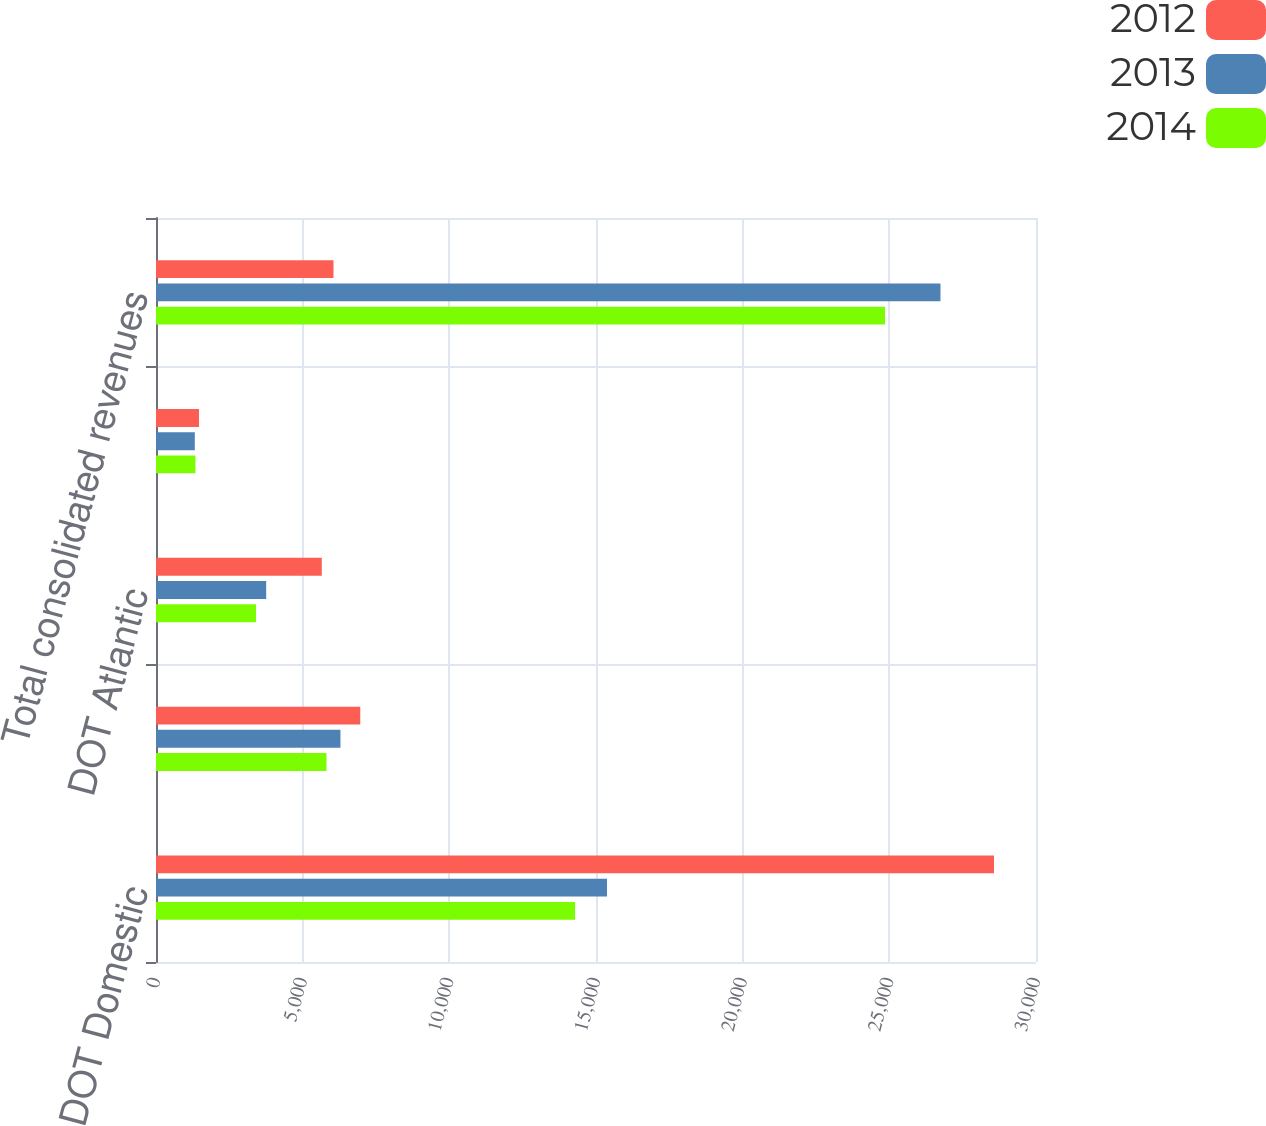<chart> <loc_0><loc_0><loc_500><loc_500><stacked_bar_chart><ecel><fcel>DOT Domestic<fcel>DOT Latin America<fcel>DOT Atlantic<fcel>DOT Pacific<fcel>Total consolidated revenues<nl><fcel>2012<fcel>28568<fcel>6964<fcel>5652<fcel>1466<fcel>6050.5<nl><fcel>2013<fcel>15376<fcel>6288<fcel>3756<fcel>1323<fcel>26743<nl><fcel>2014<fcel>14287<fcel>5813<fcel>3411<fcel>1344<fcel>24855<nl></chart> 